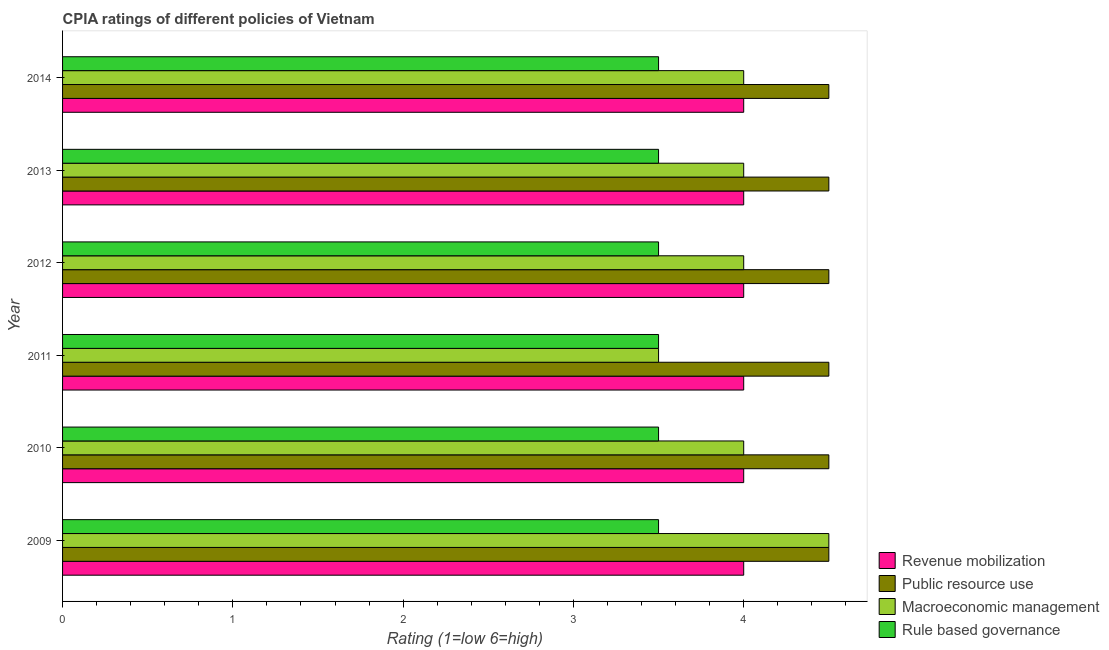How many groups of bars are there?
Your answer should be compact. 6. Are the number of bars on each tick of the Y-axis equal?
Offer a terse response. Yes. What is the cpia rating of rule based governance in 2009?
Make the answer very short. 3.5. Across all years, what is the minimum cpia rating of rule based governance?
Your response must be concise. 3.5. What is the difference between the cpia rating of public resource use in 2011 and that in 2012?
Keep it short and to the point. 0. In how many years, is the cpia rating of revenue mobilization greater than 2.6 ?
Make the answer very short. 6. Is the difference between the cpia rating of macroeconomic management in 2010 and 2011 greater than the difference between the cpia rating of rule based governance in 2010 and 2011?
Your answer should be very brief. Yes. What is the difference between the highest and the second highest cpia rating of macroeconomic management?
Offer a very short reply. 0.5. What is the difference between the highest and the lowest cpia rating of public resource use?
Your response must be concise. 0. Is it the case that in every year, the sum of the cpia rating of revenue mobilization and cpia rating of macroeconomic management is greater than the sum of cpia rating of rule based governance and cpia rating of public resource use?
Give a very brief answer. Yes. What does the 3rd bar from the top in 2012 represents?
Provide a short and direct response. Public resource use. What does the 1st bar from the bottom in 2014 represents?
Offer a terse response. Revenue mobilization. Is it the case that in every year, the sum of the cpia rating of revenue mobilization and cpia rating of public resource use is greater than the cpia rating of macroeconomic management?
Give a very brief answer. Yes. How many bars are there?
Offer a terse response. 24. Are all the bars in the graph horizontal?
Ensure brevity in your answer.  Yes. What is the difference between two consecutive major ticks on the X-axis?
Provide a succinct answer. 1. Does the graph contain grids?
Give a very brief answer. No. Where does the legend appear in the graph?
Offer a terse response. Bottom right. What is the title of the graph?
Offer a terse response. CPIA ratings of different policies of Vietnam. Does "Industry" appear as one of the legend labels in the graph?
Make the answer very short. No. What is the label or title of the X-axis?
Offer a terse response. Rating (1=low 6=high). What is the Rating (1=low 6=high) of Public resource use in 2009?
Provide a short and direct response. 4.5. What is the Rating (1=low 6=high) of Revenue mobilization in 2010?
Your response must be concise. 4. What is the Rating (1=low 6=high) in Public resource use in 2010?
Provide a short and direct response. 4.5. What is the Rating (1=low 6=high) of Macroeconomic management in 2010?
Offer a terse response. 4. What is the Rating (1=low 6=high) in Rule based governance in 2010?
Offer a terse response. 3.5. What is the Rating (1=low 6=high) in Public resource use in 2011?
Your answer should be very brief. 4.5. What is the Rating (1=low 6=high) of Macroeconomic management in 2011?
Offer a terse response. 3.5. What is the Rating (1=low 6=high) in Rule based governance in 2011?
Provide a succinct answer. 3.5. What is the Rating (1=low 6=high) of Revenue mobilization in 2012?
Ensure brevity in your answer.  4. What is the Rating (1=low 6=high) of Public resource use in 2012?
Your answer should be compact. 4.5. What is the Rating (1=low 6=high) of Rule based governance in 2012?
Offer a terse response. 3.5. What is the Rating (1=low 6=high) in Revenue mobilization in 2013?
Keep it short and to the point. 4. What is the Rating (1=low 6=high) of Rule based governance in 2013?
Give a very brief answer. 3.5. What is the Rating (1=low 6=high) in Revenue mobilization in 2014?
Ensure brevity in your answer.  4. What is the Rating (1=low 6=high) in Public resource use in 2014?
Provide a short and direct response. 4.5. Across all years, what is the maximum Rating (1=low 6=high) in Public resource use?
Offer a very short reply. 4.5. Across all years, what is the maximum Rating (1=low 6=high) in Macroeconomic management?
Provide a short and direct response. 4.5. Across all years, what is the minimum Rating (1=low 6=high) of Revenue mobilization?
Provide a succinct answer. 4. Across all years, what is the minimum Rating (1=low 6=high) of Public resource use?
Provide a short and direct response. 4.5. Across all years, what is the minimum Rating (1=low 6=high) of Macroeconomic management?
Give a very brief answer. 3.5. Across all years, what is the minimum Rating (1=low 6=high) in Rule based governance?
Your answer should be compact. 3.5. What is the total Rating (1=low 6=high) of Public resource use in the graph?
Offer a terse response. 27. What is the total Rating (1=low 6=high) in Macroeconomic management in the graph?
Your answer should be compact. 24. What is the difference between the Rating (1=low 6=high) of Revenue mobilization in 2009 and that in 2010?
Offer a very short reply. 0. What is the difference between the Rating (1=low 6=high) of Macroeconomic management in 2009 and that in 2010?
Your answer should be very brief. 0.5. What is the difference between the Rating (1=low 6=high) in Public resource use in 2009 and that in 2011?
Give a very brief answer. 0. What is the difference between the Rating (1=low 6=high) in Revenue mobilization in 2009 and that in 2012?
Your response must be concise. 0. What is the difference between the Rating (1=low 6=high) in Macroeconomic management in 2009 and that in 2012?
Offer a terse response. 0.5. What is the difference between the Rating (1=low 6=high) of Rule based governance in 2009 and that in 2013?
Provide a succinct answer. 0. What is the difference between the Rating (1=low 6=high) of Macroeconomic management in 2009 and that in 2014?
Make the answer very short. 0.5. What is the difference between the Rating (1=low 6=high) in Rule based governance in 2009 and that in 2014?
Keep it short and to the point. 0. What is the difference between the Rating (1=low 6=high) in Revenue mobilization in 2010 and that in 2011?
Offer a very short reply. 0. What is the difference between the Rating (1=low 6=high) in Macroeconomic management in 2010 and that in 2011?
Offer a very short reply. 0.5. What is the difference between the Rating (1=low 6=high) in Macroeconomic management in 2010 and that in 2012?
Your answer should be very brief. 0. What is the difference between the Rating (1=low 6=high) in Revenue mobilization in 2010 and that in 2013?
Offer a terse response. 0. What is the difference between the Rating (1=low 6=high) of Rule based governance in 2010 and that in 2013?
Provide a succinct answer. 0. What is the difference between the Rating (1=low 6=high) in Revenue mobilization in 2010 and that in 2014?
Keep it short and to the point. 0. What is the difference between the Rating (1=low 6=high) of Rule based governance in 2010 and that in 2014?
Your answer should be compact. 0. What is the difference between the Rating (1=low 6=high) in Revenue mobilization in 2011 and that in 2012?
Keep it short and to the point. 0. What is the difference between the Rating (1=low 6=high) in Public resource use in 2011 and that in 2012?
Provide a succinct answer. 0. What is the difference between the Rating (1=low 6=high) in Macroeconomic management in 2011 and that in 2012?
Provide a short and direct response. -0.5. What is the difference between the Rating (1=low 6=high) in Rule based governance in 2011 and that in 2012?
Make the answer very short. 0. What is the difference between the Rating (1=low 6=high) in Revenue mobilization in 2011 and that in 2013?
Ensure brevity in your answer.  0. What is the difference between the Rating (1=low 6=high) of Public resource use in 2011 and that in 2013?
Provide a short and direct response. 0. What is the difference between the Rating (1=low 6=high) in Macroeconomic management in 2011 and that in 2013?
Keep it short and to the point. -0.5. What is the difference between the Rating (1=low 6=high) of Public resource use in 2011 and that in 2014?
Keep it short and to the point. 0. What is the difference between the Rating (1=low 6=high) of Macroeconomic management in 2011 and that in 2014?
Offer a very short reply. -0.5. What is the difference between the Rating (1=low 6=high) in Rule based governance in 2011 and that in 2014?
Ensure brevity in your answer.  0. What is the difference between the Rating (1=low 6=high) of Revenue mobilization in 2012 and that in 2013?
Ensure brevity in your answer.  0. What is the difference between the Rating (1=low 6=high) in Macroeconomic management in 2012 and that in 2013?
Provide a succinct answer. 0. What is the difference between the Rating (1=low 6=high) of Rule based governance in 2012 and that in 2013?
Provide a succinct answer. 0. What is the difference between the Rating (1=low 6=high) of Public resource use in 2012 and that in 2014?
Provide a succinct answer. 0. What is the difference between the Rating (1=low 6=high) in Macroeconomic management in 2012 and that in 2014?
Your answer should be compact. 0. What is the difference between the Rating (1=low 6=high) in Rule based governance in 2012 and that in 2014?
Offer a terse response. 0. What is the difference between the Rating (1=low 6=high) in Revenue mobilization in 2013 and that in 2014?
Keep it short and to the point. 0. What is the difference between the Rating (1=low 6=high) of Public resource use in 2013 and that in 2014?
Make the answer very short. 0. What is the difference between the Rating (1=low 6=high) in Rule based governance in 2013 and that in 2014?
Offer a very short reply. 0. What is the difference between the Rating (1=low 6=high) in Public resource use in 2009 and the Rating (1=low 6=high) in Macroeconomic management in 2010?
Provide a short and direct response. 0.5. What is the difference between the Rating (1=low 6=high) of Macroeconomic management in 2009 and the Rating (1=low 6=high) of Rule based governance in 2010?
Your answer should be very brief. 1. What is the difference between the Rating (1=low 6=high) of Public resource use in 2009 and the Rating (1=low 6=high) of Macroeconomic management in 2011?
Offer a very short reply. 1. What is the difference between the Rating (1=low 6=high) in Public resource use in 2009 and the Rating (1=low 6=high) in Macroeconomic management in 2012?
Provide a short and direct response. 0.5. What is the difference between the Rating (1=low 6=high) of Public resource use in 2009 and the Rating (1=low 6=high) of Rule based governance in 2013?
Provide a short and direct response. 1. What is the difference between the Rating (1=low 6=high) in Macroeconomic management in 2009 and the Rating (1=low 6=high) in Rule based governance in 2013?
Your answer should be very brief. 1. What is the difference between the Rating (1=low 6=high) in Revenue mobilization in 2009 and the Rating (1=low 6=high) in Public resource use in 2014?
Offer a very short reply. -0.5. What is the difference between the Rating (1=low 6=high) in Revenue mobilization in 2009 and the Rating (1=low 6=high) in Rule based governance in 2014?
Give a very brief answer. 0.5. What is the difference between the Rating (1=low 6=high) of Public resource use in 2009 and the Rating (1=low 6=high) of Macroeconomic management in 2014?
Give a very brief answer. 0.5. What is the difference between the Rating (1=low 6=high) of Public resource use in 2009 and the Rating (1=low 6=high) of Rule based governance in 2014?
Ensure brevity in your answer.  1. What is the difference between the Rating (1=low 6=high) of Revenue mobilization in 2010 and the Rating (1=low 6=high) of Public resource use in 2011?
Offer a very short reply. -0.5. What is the difference between the Rating (1=low 6=high) of Revenue mobilization in 2010 and the Rating (1=low 6=high) of Macroeconomic management in 2011?
Ensure brevity in your answer.  0.5. What is the difference between the Rating (1=low 6=high) of Macroeconomic management in 2010 and the Rating (1=low 6=high) of Rule based governance in 2011?
Keep it short and to the point. 0.5. What is the difference between the Rating (1=low 6=high) of Revenue mobilization in 2010 and the Rating (1=low 6=high) of Macroeconomic management in 2012?
Ensure brevity in your answer.  0. What is the difference between the Rating (1=low 6=high) of Public resource use in 2010 and the Rating (1=low 6=high) of Rule based governance in 2012?
Your answer should be very brief. 1. What is the difference between the Rating (1=low 6=high) of Public resource use in 2010 and the Rating (1=low 6=high) of Macroeconomic management in 2013?
Your answer should be very brief. 0.5. What is the difference between the Rating (1=low 6=high) in Public resource use in 2010 and the Rating (1=low 6=high) in Rule based governance in 2013?
Ensure brevity in your answer.  1. What is the difference between the Rating (1=low 6=high) of Revenue mobilization in 2010 and the Rating (1=low 6=high) of Macroeconomic management in 2014?
Your answer should be compact. 0. What is the difference between the Rating (1=low 6=high) of Public resource use in 2010 and the Rating (1=low 6=high) of Macroeconomic management in 2014?
Your answer should be very brief. 0.5. What is the difference between the Rating (1=low 6=high) in Revenue mobilization in 2011 and the Rating (1=low 6=high) in Macroeconomic management in 2012?
Your answer should be very brief. 0. What is the difference between the Rating (1=low 6=high) in Revenue mobilization in 2011 and the Rating (1=low 6=high) in Rule based governance in 2012?
Offer a terse response. 0.5. What is the difference between the Rating (1=low 6=high) in Public resource use in 2011 and the Rating (1=low 6=high) in Macroeconomic management in 2012?
Offer a terse response. 0.5. What is the difference between the Rating (1=low 6=high) in Public resource use in 2011 and the Rating (1=low 6=high) in Rule based governance in 2012?
Your answer should be very brief. 1. What is the difference between the Rating (1=low 6=high) of Revenue mobilization in 2011 and the Rating (1=low 6=high) of Rule based governance in 2013?
Offer a very short reply. 0.5. What is the difference between the Rating (1=low 6=high) of Public resource use in 2011 and the Rating (1=low 6=high) of Macroeconomic management in 2013?
Give a very brief answer. 0.5. What is the difference between the Rating (1=low 6=high) in Revenue mobilization in 2011 and the Rating (1=low 6=high) in Macroeconomic management in 2014?
Keep it short and to the point. 0. What is the difference between the Rating (1=low 6=high) of Revenue mobilization in 2011 and the Rating (1=low 6=high) of Rule based governance in 2014?
Keep it short and to the point. 0.5. What is the difference between the Rating (1=low 6=high) of Revenue mobilization in 2012 and the Rating (1=low 6=high) of Public resource use in 2013?
Your answer should be compact. -0.5. What is the difference between the Rating (1=low 6=high) of Revenue mobilization in 2012 and the Rating (1=low 6=high) of Macroeconomic management in 2013?
Give a very brief answer. 0. What is the difference between the Rating (1=low 6=high) in Revenue mobilization in 2012 and the Rating (1=low 6=high) in Rule based governance in 2013?
Ensure brevity in your answer.  0.5. What is the difference between the Rating (1=low 6=high) in Public resource use in 2012 and the Rating (1=low 6=high) in Macroeconomic management in 2013?
Make the answer very short. 0.5. What is the difference between the Rating (1=low 6=high) of Macroeconomic management in 2012 and the Rating (1=low 6=high) of Rule based governance in 2013?
Your answer should be very brief. 0.5. What is the difference between the Rating (1=low 6=high) of Revenue mobilization in 2012 and the Rating (1=low 6=high) of Public resource use in 2014?
Your answer should be compact. -0.5. What is the difference between the Rating (1=low 6=high) in Revenue mobilization in 2012 and the Rating (1=low 6=high) in Macroeconomic management in 2014?
Give a very brief answer. 0. What is the difference between the Rating (1=low 6=high) in Public resource use in 2012 and the Rating (1=low 6=high) in Rule based governance in 2014?
Provide a short and direct response. 1. What is the difference between the Rating (1=low 6=high) of Public resource use in 2013 and the Rating (1=low 6=high) of Macroeconomic management in 2014?
Provide a short and direct response. 0.5. What is the average Rating (1=low 6=high) of Macroeconomic management per year?
Your answer should be very brief. 4. In the year 2009, what is the difference between the Rating (1=low 6=high) in Revenue mobilization and Rating (1=low 6=high) in Public resource use?
Your response must be concise. -0.5. In the year 2009, what is the difference between the Rating (1=low 6=high) of Revenue mobilization and Rating (1=low 6=high) of Rule based governance?
Ensure brevity in your answer.  0.5. In the year 2009, what is the difference between the Rating (1=low 6=high) in Public resource use and Rating (1=low 6=high) in Macroeconomic management?
Ensure brevity in your answer.  0. In the year 2009, what is the difference between the Rating (1=low 6=high) of Public resource use and Rating (1=low 6=high) of Rule based governance?
Your answer should be compact. 1. In the year 2009, what is the difference between the Rating (1=low 6=high) of Macroeconomic management and Rating (1=low 6=high) of Rule based governance?
Your answer should be very brief. 1. In the year 2010, what is the difference between the Rating (1=low 6=high) in Revenue mobilization and Rating (1=low 6=high) in Public resource use?
Make the answer very short. -0.5. In the year 2010, what is the difference between the Rating (1=low 6=high) of Revenue mobilization and Rating (1=low 6=high) of Macroeconomic management?
Provide a short and direct response. 0. In the year 2010, what is the difference between the Rating (1=low 6=high) of Revenue mobilization and Rating (1=low 6=high) of Rule based governance?
Ensure brevity in your answer.  0.5. In the year 2010, what is the difference between the Rating (1=low 6=high) of Macroeconomic management and Rating (1=low 6=high) of Rule based governance?
Ensure brevity in your answer.  0.5. In the year 2011, what is the difference between the Rating (1=low 6=high) in Revenue mobilization and Rating (1=low 6=high) in Rule based governance?
Your answer should be compact. 0.5. In the year 2011, what is the difference between the Rating (1=low 6=high) in Public resource use and Rating (1=low 6=high) in Macroeconomic management?
Keep it short and to the point. 1. In the year 2012, what is the difference between the Rating (1=low 6=high) in Public resource use and Rating (1=low 6=high) in Macroeconomic management?
Your response must be concise. 0.5. In the year 2012, what is the difference between the Rating (1=low 6=high) of Public resource use and Rating (1=low 6=high) of Rule based governance?
Provide a succinct answer. 1. In the year 2012, what is the difference between the Rating (1=low 6=high) of Macroeconomic management and Rating (1=low 6=high) of Rule based governance?
Offer a very short reply. 0.5. In the year 2013, what is the difference between the Rating (1=low 6=high) in Revenue mobilization and Rating (1=low 6=high) in Public resource use?
Provide a succinct answer. -0.5. In the year 2013, what is the difference between the Rating (1=low 6=high) of Revenue mobilization and Rating (1=low 6=high) of Macroeconomic management?
Give a very brief answer. 0. In the year 2013, what is the difference between the Rating (1=low 6=high) in Macroeconomic management and Rating (1=low 6=high) in Rule based governance?
Your answer should be compact. 0.5. In the year 2014, what is the difference between the Rating (1=low 6=high) of Revenue mobilization and Rating (1=low 6=high) of Public resource use?
Offer a very short reply. -0.5. In the year 2014, what is the difference between the Rating (1=low 6=high) of Revenue mobilization and Rating (1=low 6=high) of Macroeconomic management?
Your answer should be compact. 0. In the year 2014, what is the difference between the Rating (1=low 6=high) in Revenue mobilization and Rating (1=low 6=high) in Rule based governance?
Your response must be concise. 0.5. In the year 2014, what is the difference between the Rating (1=low 6=high) of Public resource use and Rating (1=low 6=high) of Macroeconomic management?
Offer a terse response. 0.5. In the year 2014, what is the difference between the Rating (1=low 6=high) in Public resource use and Rating (1=low 6=high) in Rule based governance?
Your response must be concise. 1. In the year 2014, what is the difference between the Rating (1=low 6=high) in Macroeconomic management and Rating (1=low 6=high) in Rule based governance?
Keep it short and to the point. 0.5. What is the ratio of the Rating (1=low 6=high) of Revenue mobilization in 2009 to that in 2010?
Provide a short and direct response. 1. What is the ratio of the Rating (1=low 6=high) of Rule based governance in 2009 to that in 2010?
Offer a terse response. 1. What is the ratio of the Rating (1=low 6=high) of Revenue mobilization in 2009 to that in 2011?
Keep it short and to the point. 1. What is the ratio of the Rating (1=low 6=high) in Public resource use in 2009 to that in 2011?
Provide a succinct answer. 1. What is the ratio of the Rating (1=low 6=high) of Rule based governance in 2009 to that in 2011?
Your answer should be very brief. 1. What is the ratio of the Rating (1=low 6=high) of Rule based governance in 2009 to that in 2012?
Offer a terse response. 1. What is the ratio of the Rating (1=low 6=high) of Revenue mobilization in 2009 to that in 2013?
Your answer should be compact. 1. What is the ratio of the Rating (1=low 6=high) of Revenue mobilization in 2009 to that in 2014?
Ensure brevity in your answer.  1. What is the ratio of the Rating (1=low 6=high) of Public resource use in 2009 to that in 2014?
Make the answer very short. 1. What is the ratio of the Rating (1=low 6=high) in Revenue mobilization in 2010 to that in 2011?
Offer a terse response. 1. What is the ratio of the Rating (1=low 6=high) in Public resource use in 2010 to that in 2011?
Provide a short and direct response. 1. What is the ratio of the Rating (1=low 6=high) of Rule based governance in 2010 to that in 2011?
Give a very brief answer. 1. What is the ratio of the Rating (1=low 6=high) in Public resource use in 2010 to that in 2012?
Make the answer very short. 1. What is the ratio of the Rating (1=low 6=high) in Rule based governance in 2010 to that in 2012?
Your response must be concise. 1. What is the ratio of the Rating (1=low 6=high) in Revenue mobilization in 2010 to that in 2013?
Provide a succinct answer. 1. What is the ratio of the Rating (1=low 6=high) in Revenue mobilization in 2010 to that in 2014?
Provide a short and direct response. 1. What is the ratio of the Rating (1=low 6=high) in Public resource use in 2010 to that in 2014?
Provide a short and direct response. 1. What is the ratio of the Rating (1=low 6=high) of Rule based governance in 2010 to that in 2014?
Keep it short and to the point. 1. What is the ratio of the Rating (1=low 6=high) in Revenue mobilization in 2011 to that in 2012?
Offer a terse response. 1. What is the ratio of the Rating (1=low 6=high) of Public resource use in 2011 to that in 2012?
Keep it short and to the point. 1. What is the ratio of the Rating (1=low 6=high) of Public resource use in 2011 to that in 2013?
Your answer should be very brief. 1. What is the ratio of the Rating (1=low 6=high) in Macroeconomic management in 2011 to that in 2013?
Provide a short and direct response. 0.88. What is the ratio of the Rating (1=low 6=high) in Macroeconomic management in 2011 to that in 2014?
Your answer should be very brief. 0.88. What is the ratio of the Rating (1=low 6=high) of Rule based governance in 2011 to that in 2014?
Your answer should be very brief. 1. What is the ratio of the Rating (1=low 6=high) of Public resource use in 2012 to that in 2013?
Keep it short and to the point. 1. What is the ratio of the Rating (1=low 6=high) of Macroeconomic management in 2012 to that in 2013?
Keep it short and to the point. 1. What is the ratio of the Rating (1=low 6=high) of Rule based governance in 2012 to that in 2013?
Provide a short and direct response. 1. What is the ratio of the Rating (1=low 6=high) in Revenue mobilization in 2012 to that in 2014?
Offer a terse response. 1. What is the ratio of the Rating (1=low 6=high) of Revenue mobilization in 2013 to that in 2014?
Provide a succinct answer. 1. What is the ratio of the Rating (1=low 6=high) of Public resource use in 2013 to that in 2014?
Your response must be concise. 1. What is the difference between the highest and the second highest Rating (1=low 6=high) of Public resource use?
Make the answer very short. 0. What is the difference between the highest and the second highest Rating (1=low 6=high) of Rule based governance?
Your response must be concise. 0. What is the difference between the highest and the lowest Rating (1=low 6=high) of Public resource use?
Make the answer very short. 0. What is the difference between the highest and the lowest Rating (1=low 6=high) of Macroeconomic management?
Offer a terse response. 1. What is the difference between the highest and the lowest Rating (1=low 6=high) in Rule based governance?
Provide a succinct answer. 0. 